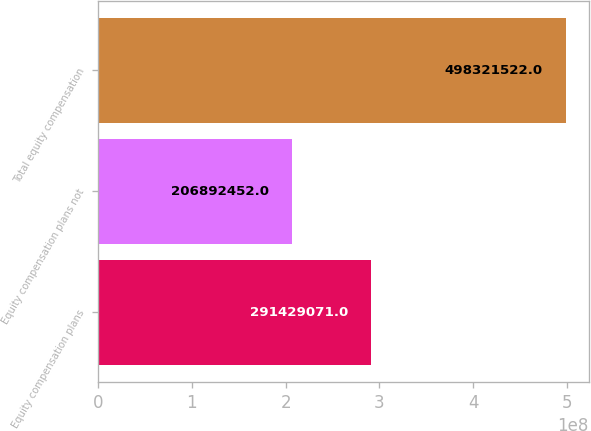Convert chart. <chart><loc_0><loc_0><loc_500><loc_500><bar_chart><fcel>Equity compensation plans<fcel>Equity compensation plans not<fcel>Total equity compensation<nl><fcel>2.91429e+08<fcel>2.06892e+08<fcel>4.98322e+08<nl></chart> 